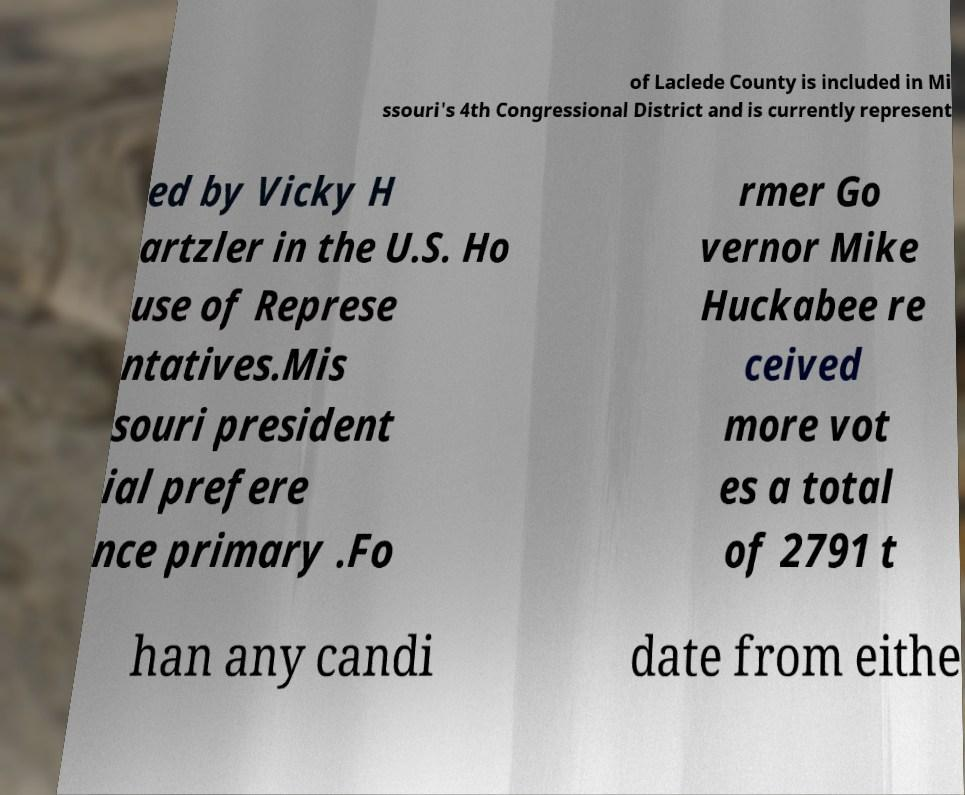There's text embedded in this image that I need extracted. Can you transcribe it verbatim? of Laclede County is included in Mi ssouri's 4th Congressional District and is currently represent ed by Vicky H artzler in the U.S. Ho use of Represe ntatives.Mis souri president ial prefere nce primary .Fo rmer Go vernor Mike Huckabee re ceived more vot es a total of 2791 t han any candi date from eithe 